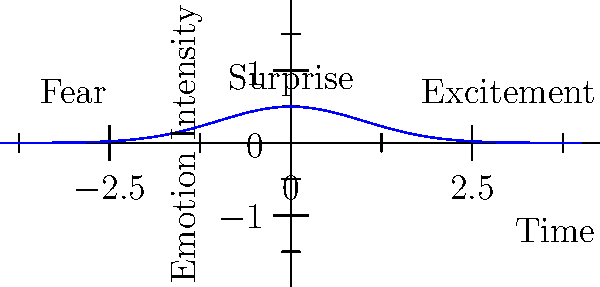As a paranormal investigator using facial recognition technology to analyze emotions during investigations, which emotion pattern does the graph most likely represent in terms of intensity over time, and how might this relate to a typical paranormal experience? To answer this question, let's analyze the graph step-by-step:

1. The x-axis represents time, and the y-axis represents emotion intensity.

2. The curve shows a bell-shaped distribution, peaking in the middle and tapering off at both ends.

3. This pattern is typical of a Gaussian or normal distribution, often seen in emotional responses during sudden events.

4. In the context of paranormal investigations:
   a) The left side (labeled "Fear") shows a rapid increase in emotion intensity.
   b) The peak (labeled "Surprise") represents the highest intensity of emotion.
   c) The right side (labeled "Excitement") shows a gradual decrease in intensity.

5. This pattern aligns with a common emotional progression during paranormal experiences:
   a) Initial fear or apprehension as something unusual is perceived.
   b) A sudden peak of surprise when the paranormal event occurs.
   c) Followed by excitement or awe as the investigator processes the experience.

6. From a psychological perspective, this emotional pattern reflects:
   a) The initial activation of the fight-or-flight response (fear).
   b) The moment of realization or confrontation with the unexpected (surprise).
   c) The cognitive processing and potential reframing of the experience (excitement).

7. For a paranormal investigator, recognizing this pattern could help in:
   a) Identifying genuine reactions to paranormal phenomena.
   b) Distinguishing between actual experiences and false positives.
   c) Understanding the psychological impact of investigations on team members.

Given these factors, the graph most likely represents the emotional intensity pattern of surprise during a typical paranormal experience, characterized by a rapid onset, intense peak, and gradual decline.
Answer: Surprise during a paranormal encounter 